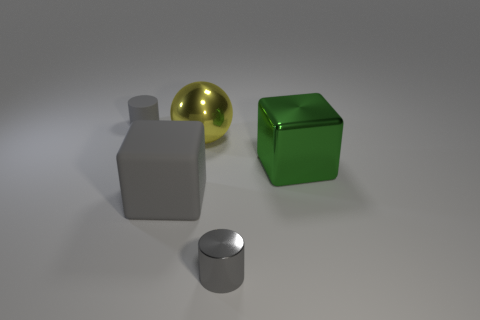What is the material of the gray object behind the big green object that is on the right side of the large metallic sphere?
Give a very brief answer. Rubber. What number of things are both on the left side of the yellow shiny thing and behind the large gray rubber block?
Your answer should be compact. 1. How many other things are the same size as the yellow shiny thing?
Offer a very short reply. 2. There is a large thing that is on the right side of the big yellow shiny thing; is it the same shape as the gray object that is behind the large green metallic thing?
Give a very brief answer. No. Are there any big cubes behind the large green object?
Ensure brevity in your answer.  No. What is the color of the large matte thing that is the same shape as the green metallic object?
Ensure brevity in your answer.  Gray. Is there any other thing that is the same shape as the small gray rubber object?
Give a very brief answer. Yes. What is the material of the small cylinder in front of the big ball?
Keep it short and to the point. Metal. There is a gray thing that is the same shape as the green metal thing; what is its size?
Offer a terse response. Large. How many small gray things have the same material as the big gray block?
Your answer should be very brief. 1. 